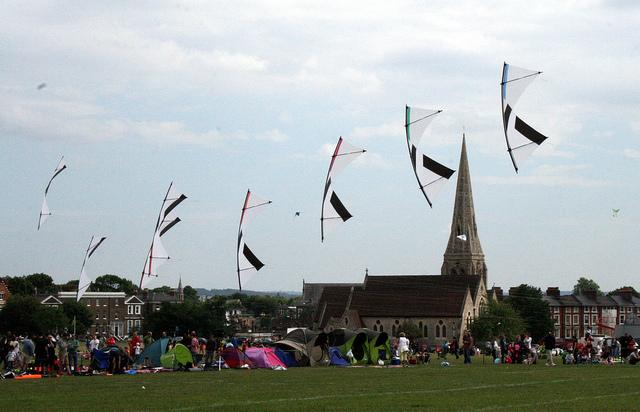What might be taking place in the building to the right? Please explain your reasoning. worship service. It is a church with a tall steeple. 